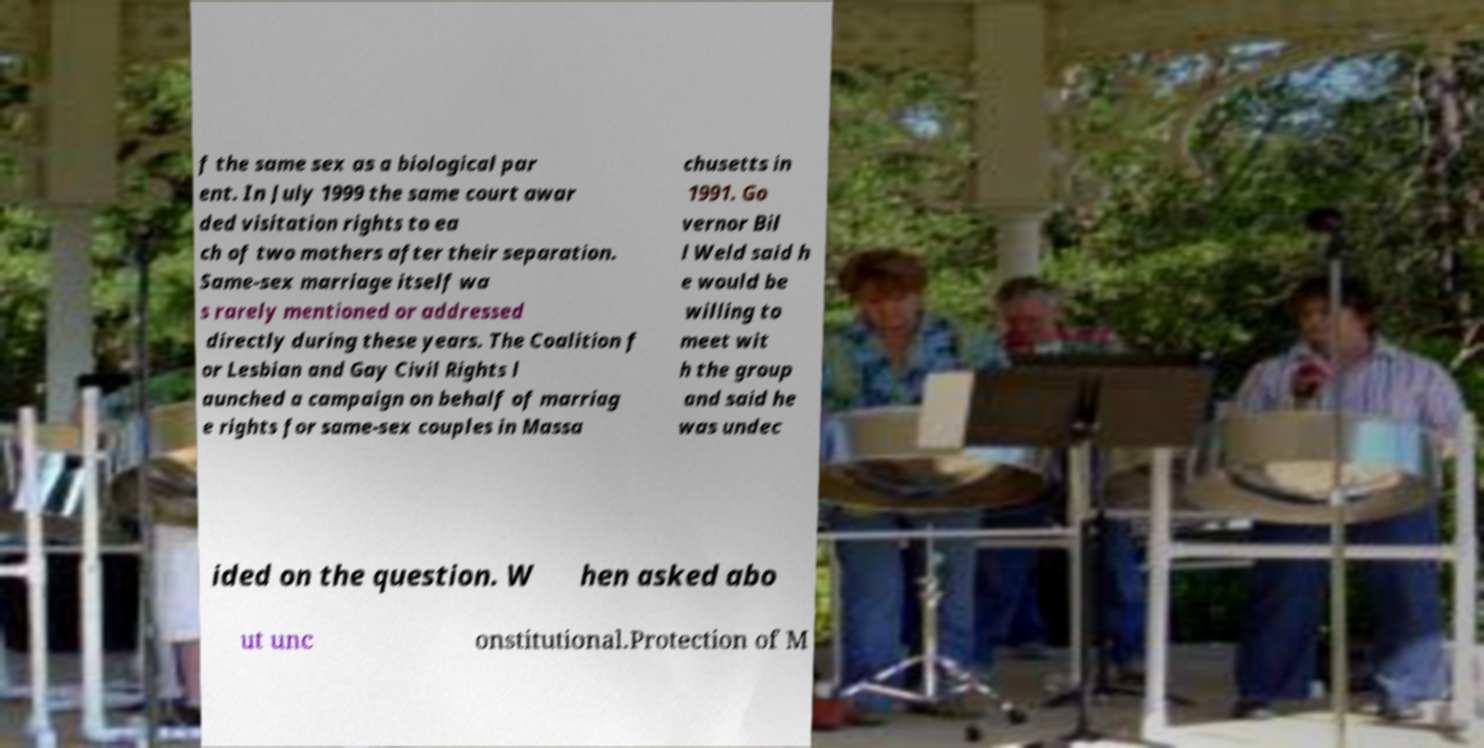There's text embedded in this image that I need extracted. Can you transcribe it verbatim? f the same sex as a biological par ent. In July 1999 the same court awar ded visitation rights to ea ch of two mothers after their separation. Same-sex marriage itself wa s rarely mentioned or addressed directly during these years. The Coalition f or Lesbian and Gay Civil Rights l aunched a campaign on behalf of marriag e rights for same-sex couples in Massa chusetts in 1991. Go vernor Bil l Weld said h e would be willing to meet wit h the group and said he was undec ided on the question. W hen asked abo ut unc onstitutional.Protection of M 